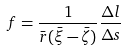Convert formula to latex. <formula><loc_0><loc_0><loc_500><loc_500>f = \frac { 1 } { \bar { r } ( \bar { \xi } - \bar { \zeta } ) } \frac { \Delta l } { \Delta s }</formula> 